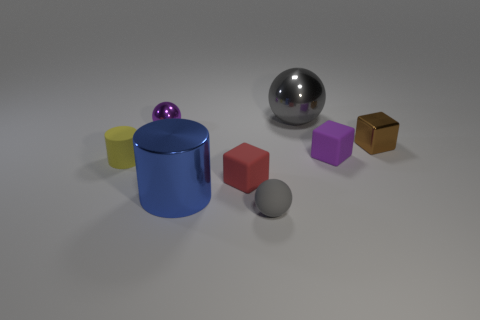What number of rubber objects are small yellow things or tiny gray objects?
Give a very brief answer. 2. Is the color of the large metal sphere the same as the matte ball?
Offer a terse response. Yes. Is there anything else of the same color as the large metal cylinder?
Offer a terse response. No. Is the shape of the purple thing on the right side of the shiny cylinder the same as the small metallic thing that is right of the small gray sphere?
Provide a short and direct response. Yes. How many things are gray matte spheres or small gray rubber objects that are in front of the tiny metal cube?
Give a very brief answer. 1. What number of other objects are the same size as the red object?
Offer a very short reply. 5. Does the small sphere that is to the left of the tiny rubber ball have the same material as the gray object in front of the small red matte block?
Make the answer very short. No. How many brown cubes are left of the tiny purple metallic ball?
Make the answer very short. 0. How many red objects are either big spheres or objects?
Ensure brevity in your answer.  1. There is a red object that is the same size as the metallic block; what is it made of?
Provide a short and direct response. Rubber. 